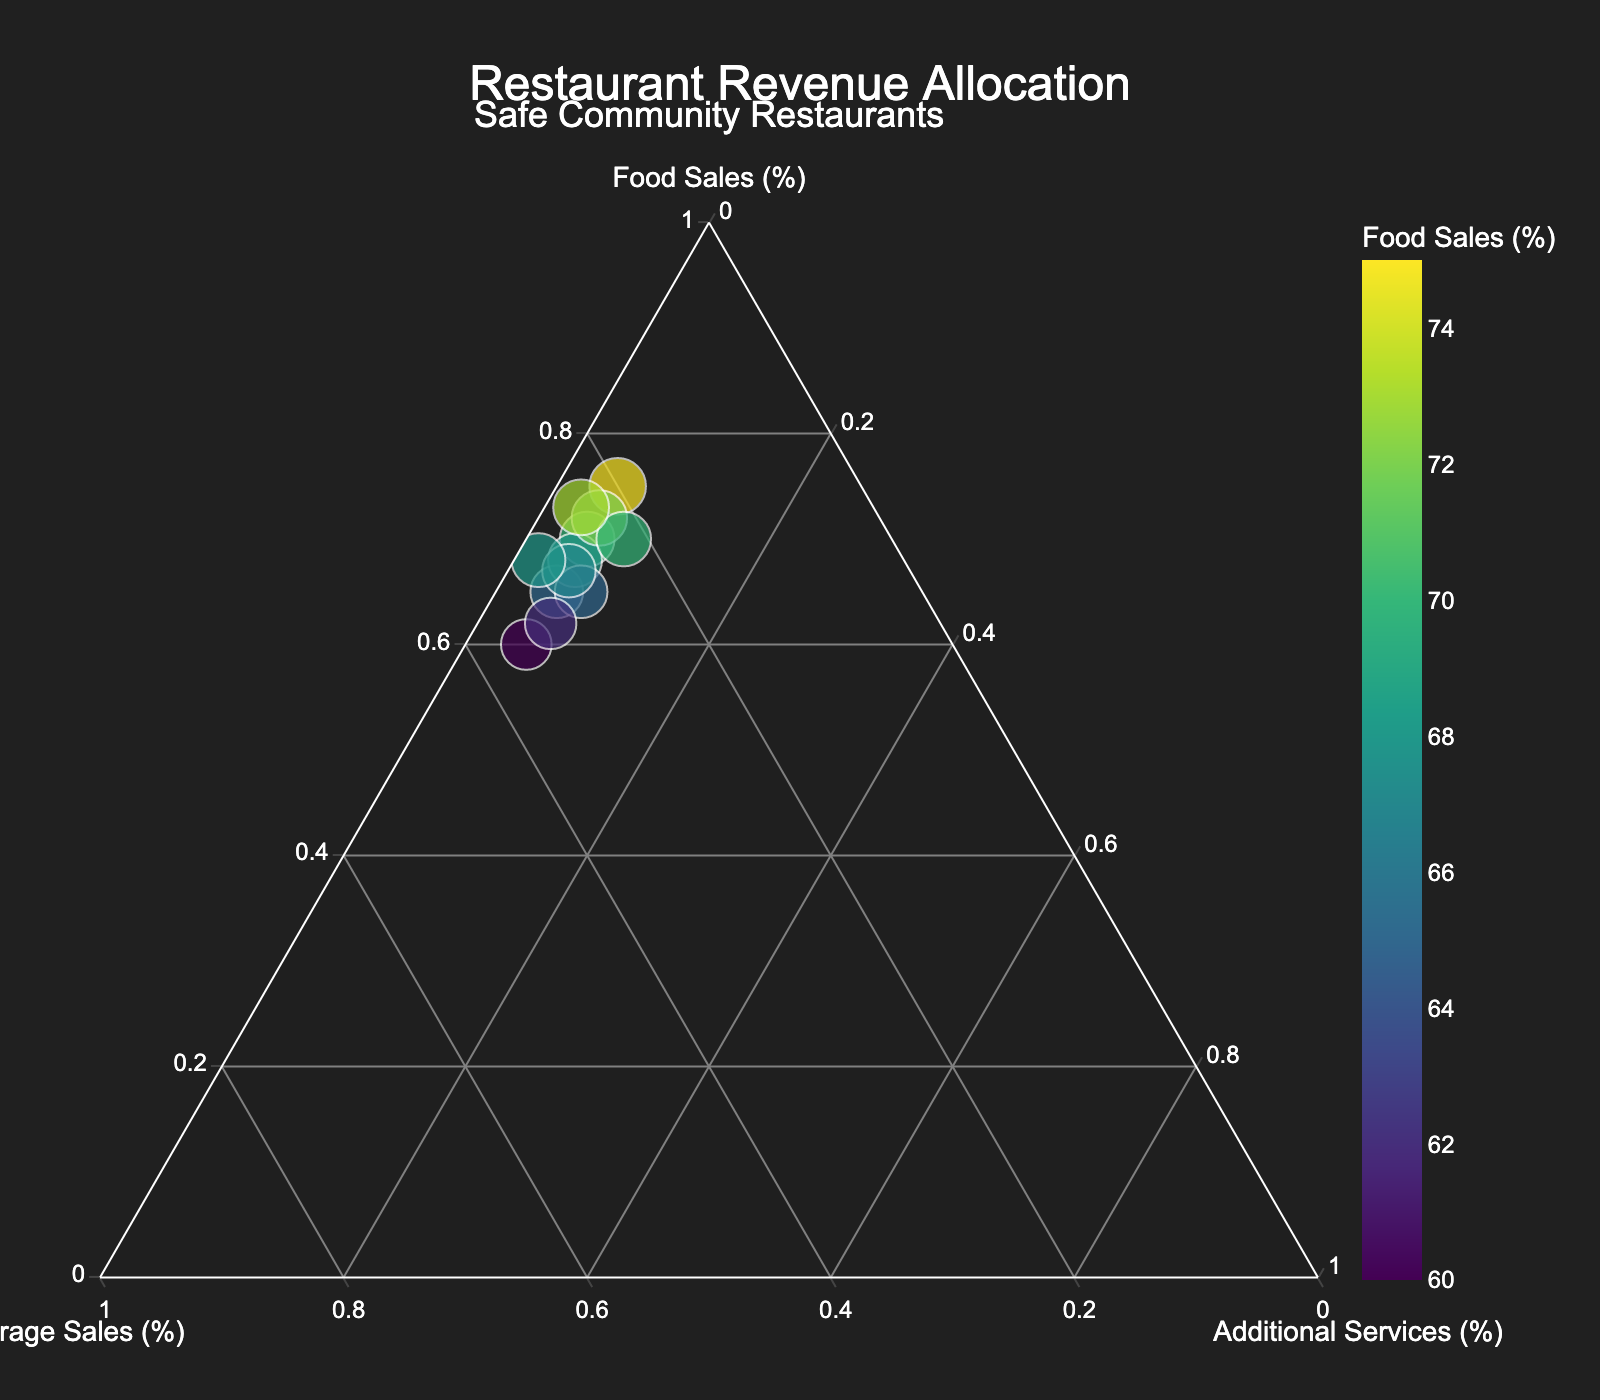What is the title of the figure? The title of the figure can be found at the top center detailing the main topic of the plot. The title reads "Restaurant Revenue Allocation".
Answer: Restaurant Revenue Allocation How many restaurants have a higher proportion of "Beverage Sales" compared to the "Food Sales"? By observing the plot and comparing each data point's position, a higher proportion of "Beverage Sales" than "Food Sales" would be closer to the Beverage Sales vertex. None of the plotted restaurants fall into this category, indicating it's zero.
Answer: 0 Which restaurant has the highest percentage attributed to "Additional Services"? Look for the restaurant that is closest to the vertex representing "Additional Services" in the plot. "Friendly Fare" located near that vertex with 8% allocation.
Answer: Friendly Fare Is there a significant correlation between "Food Sales" and "Additional Services"? By visual inspection, if most points with higher "Food Sales" percentages (closer to the Food Sales vertex) have similar or a pattern in their "Additional Services", there may be a correlation. The uniformity in "Additional Services" (mostly 5%) indicates no strong correlation.
Answer: No Which restaurant shows a more balanced distribution of revenue among all three categories? A balanced revenue allocation would be represented by a point near the center of the ternary plot. "Safe Haven Cafe" with values 65, 28, and 7 respectively appears closest to the center.
Answer: Safe Haven Cafe What is the average percentage allocation of "Food Sales" across all restaurants? Add all "Food Sales" values and divide by the number of restaurants. Total is (70+65+75+68+72+60+65+62+70+67+73+68) = 815 divided by 12 restaurants. 815 / 12 ≈ 67.92%.
Answer: 67.92% Which restaurant has the lowest proportion allocated to "Additional Services"? Find the data point closest to the edge opposite the "Additional Services" vertex. "Main Street Diner" shows the lowest proportion with 2%.
Answer: Main Street Diner Is there any restaurant where "Beverage Sales" is approximately half of "Food Sales"? Compare each point where the proportion of "Beverage Sales" is roughly half of "Food Sales". Both approximate but "Main Street Diner" (68 vs 30) and "Neighborhood Bistro" (60 vs 35) have ratios near to this condition.
Answer: Main Street Diner & Neighborhood Bistro 